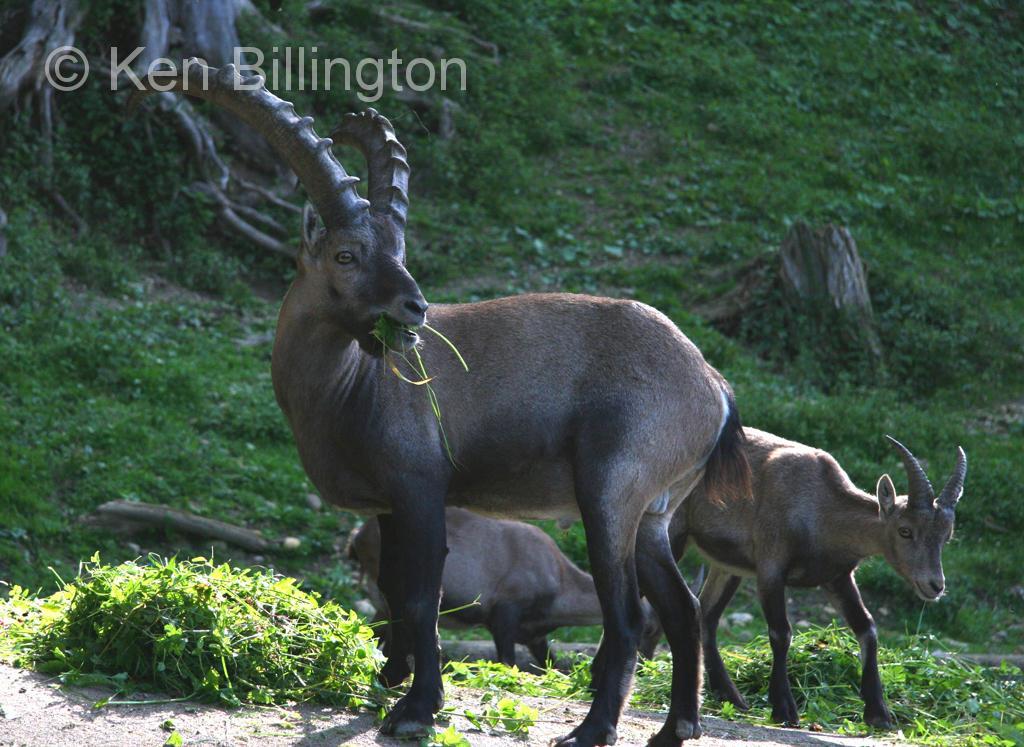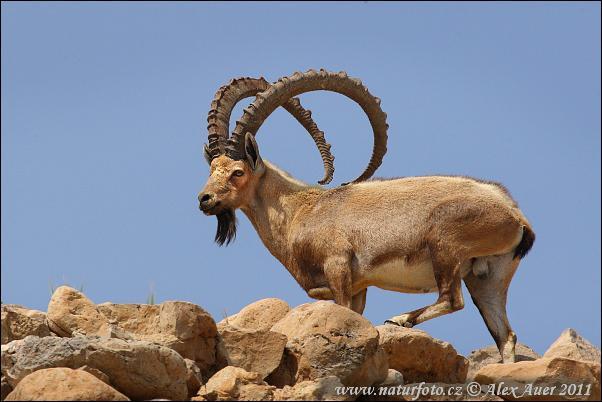The first image is the image on the left, the second image is the image on the right. Assess this claim about the two images: "There are at least two animals in the image on the left.". Correct or not? Answer yes or no. Yes. 